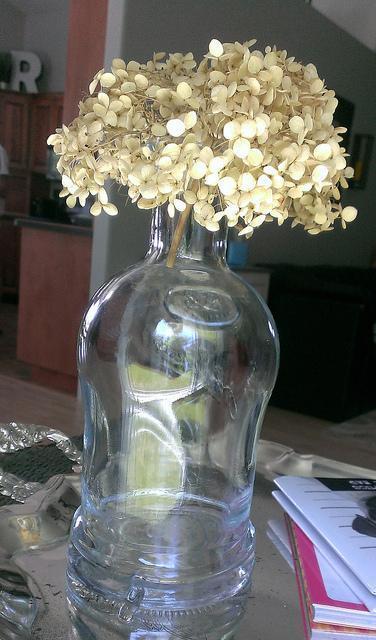How many books can you see?
Give a very brief answer. 2. How many trains are to the left of the doors?
Give a very brief answer. 0. 